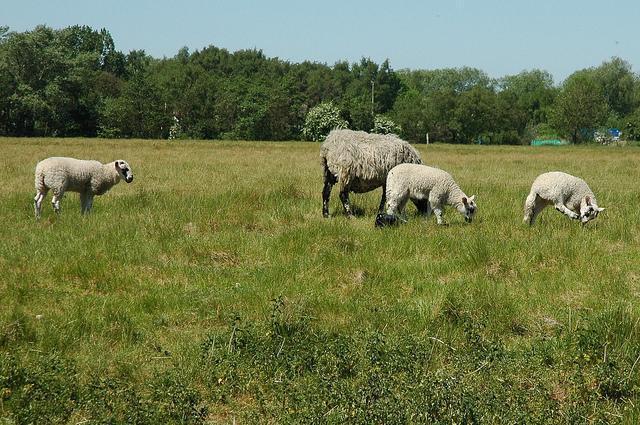How many animals are in the picture?
Give a very brief answer. 4. How many sheep are there?
Give a very brief answer. 4. How many men are there?
Give a very brief answer. 0. 